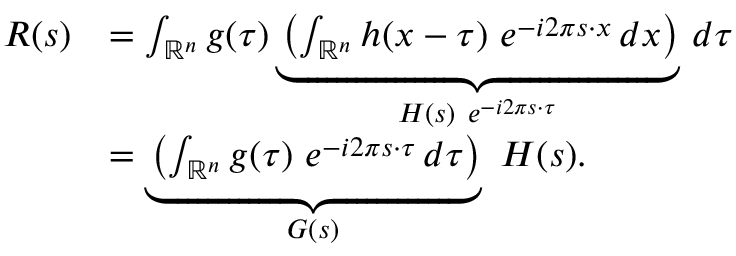<formula> <loc_0><loc_0><loc_500><loc_500>{ \begin{array} { r l } { R ( s ) } & { = \int _ { \mathbb { R } ^ { n } } g ( \tau ) \underbrace { \left ( \int _ { \mathbb { R } ^ { n } } h ( x - \tau ) \ e ^ { - i 2 \pi s \cdot x } \, d x \right ) } _ { H ( s ) \ e ^ { - i 2 \pi s \cdot \tau } } \, d \tau } \\ & { = \underbrace { \left ( \int _ { \mathbb { R } ^ { n } } g ( \tau ) \ e ^ { - i 2 \pi s \cdot \tau } \, d \tau \right ) } _ { G ( s ) } \ H ( s ) . } \end{array} }</formula> 